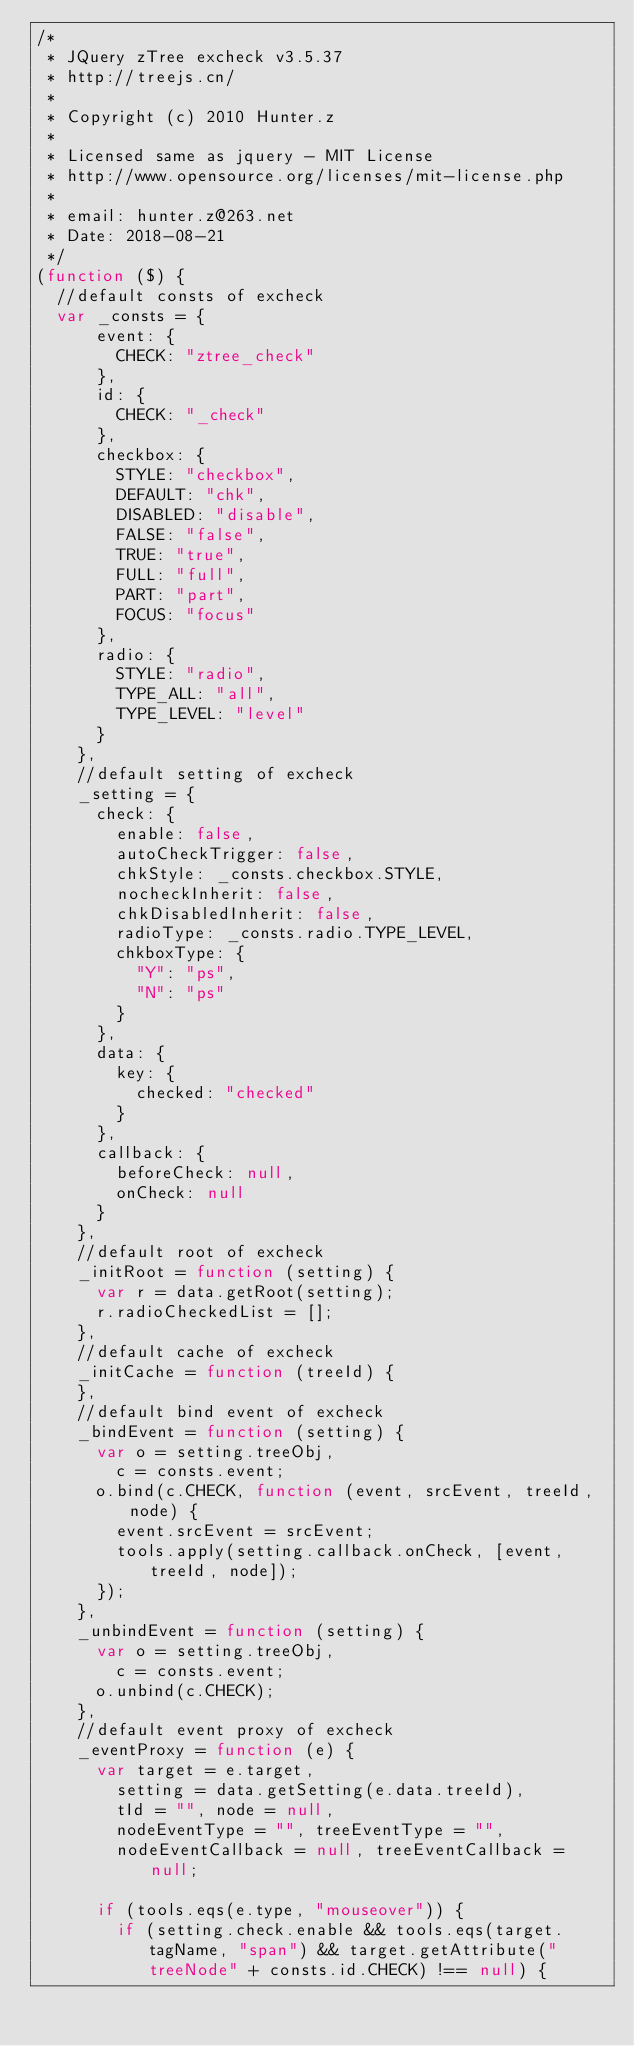Convert code to text. <code><loc_0><loc_0><loc_500><loc_500><_JavaScript_>/*
 * JQuery zTree excheck v3.5.37
 * http://treejs.cn/
 *
 * Copyright (c) 2010 Hunter.z
 *
 * Licensed same as jquery - MIT License
 * http://www.opensource.org/licenses/mit-license.php
 *
 * email: hunter.z@263.net
 * Date: 2018-08-21
 */
(function ($) {
  //default consts of excheck
  var _consts = {
      event: {
        CHECK: "ztree_check"
      },
      id: {
        CHECK: "_check"
      },
      checkbox: {
        STYLE: "checkbox",
        DEFAULT: "chk",
        DISABLED: "disable",
        FALSE: "false",
        TRUE: "true",
        FULL: "full",
        PART: "part",
        FOCUS: "focus"
      },
      radio: {
        STYLE: "radio",
        TYPE_ALL: "all",
        TYPE_LEVEL: "level"
      }
    },
    //default setting of excheck
    _setting = {
      check: {
        enable: false,
        autoCheckTrigger: false,
        chkStyle: _consts.checkbox.STYLE,
        nocheckInherit: false,
        chkDisabledInherit: false,
        radioType: _consts.radio.TYPE_LEVEL,
        chkboxType: {
          "Y": "ps",
          "N": "ps"
        }
      },
      data: {
        key: {
          checked: "checked"
        }
      },
      callback: {
        beforeCheck: null,
        onCheck: null
      }
    },
    //default root of excheck
    _initRoot = function (setting) {
      var r = data.getRoot(setting);
      r.radioCheckedList = [];
    },
    //default cache of excheck
    _initCache = function (treeId) {
    },
    //default bind event of excheck
    _bindEvent = function (setting) {
      var o = setting.treeObj,
        c = consts.event;
      o.bind(c.CHECK, function (event, srcEvent, treeId, node) {
        event.srcEvent = srcEvent;
        tools.apply(setting.callback.onCheck, [event, treeId, node]);
      });
    },
    _unbindEvent = function (setting) {
      var o = setting.treeObj,
        c = consts.event;
      o.unbind(c.CHECK);
    },
    //default event proxy of excheck
    _eventProxy = function (e) {
      var target = e.target,
        setting = data.getSetting(e.data.treeId),
        tId = "", node = null,
        nodeEventType = "", treeEventType = "",
        nodeEventCallback = null, treeEventCallback = null;

      if (tools.eqs(e.type, "mouseover")) {
        if (setting.check.enable && tools.eqs(target.tagName, "span") && target.getAttribute("treeNode" + consts.id.CHECK) !== null) {</code> 